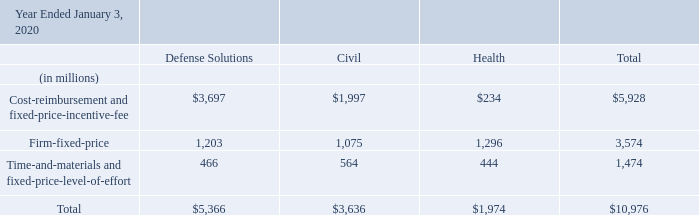The majority of the Company's revenues are generated from U.S. government contracts, either as a prime contractor or as a subcontractor to other contractors. Revenues from the U.S. government can be adversely impacted by spending caps or changes in budgetary priorities of the U.S. government, as well as delays in program start dates or the award of a contract.
Disaggregated revenues by contract-type were as follows:
Where are the Company's majority revenues generated from? U.s. government contracts, either as a prime contractor or as a subcontractor to other contractors. What was the Cost-reimbursement and fixed-price-incentive-fee in Defense Solutions, Civil and Health respectively?
Answer scale should be: million. $3,697, $1,997, $234. What was the total Firm-fixed-price?
Answer scale should be: million. 3,574. In which category was Cost-reimbursement and fixed-price-incentive-fee more than 1,000 million? Locate and analyze cost-reimbursement and fixed-price-incentive-fee in row 5
answer: defense solutions, civil. What was the difference in the Cost-reimbursement and fixed-price-incentive-fee between Civil and Health?
Answer scale should be: million. 1,997 - 234
Answer: 1763. What was the average Firm-fixed-price under Solutions, Civil and Health?
Answer scale should be: million. (1,203 + 1,075 + 1,296) / 3
Answer: 1191.33. 